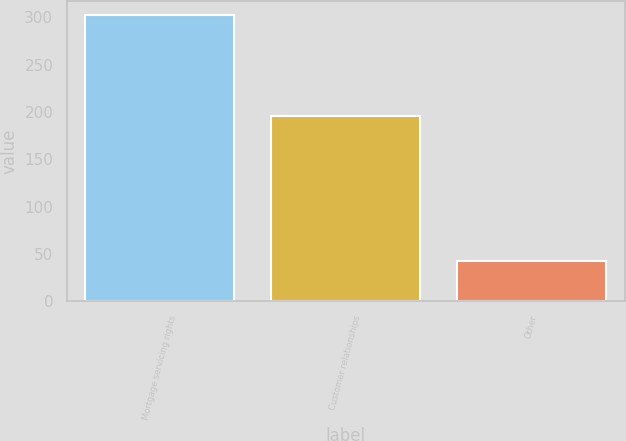<chart> <loc_0><loc_0><loc_500><loc_500><bar_chart><fcel>Mortgage servicing rights<fcel>Customer relationships<fcel>Other<nl><fcel>302<fcel>196<fcel>42<nl></chart> 